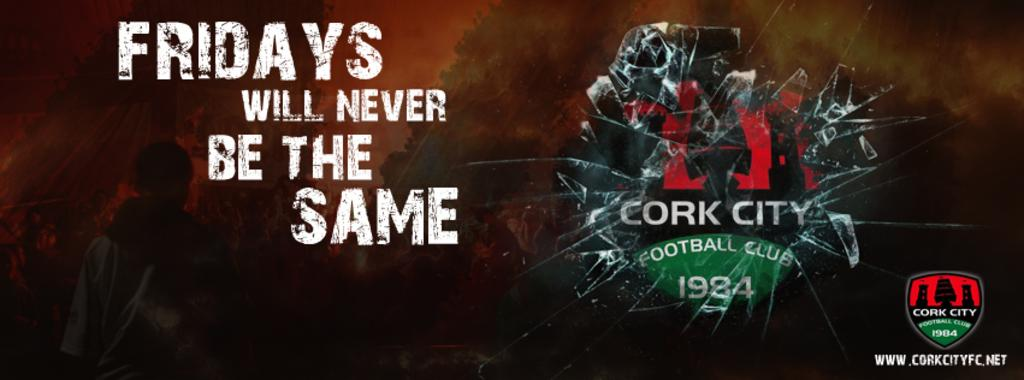<image>
Provide a brief description of the given image. a screen that says 'fridays will never be the same' on it 